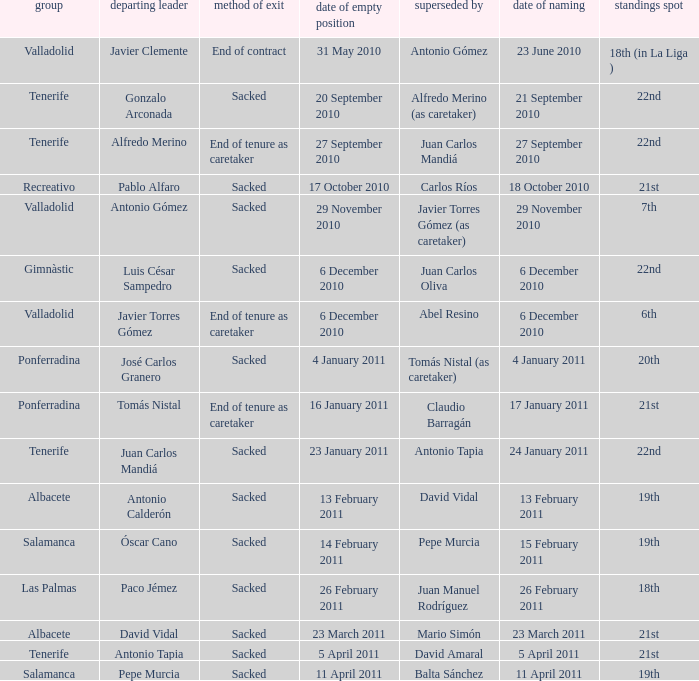How many teams had an outgoing manager of antonio gómez 1.0. 